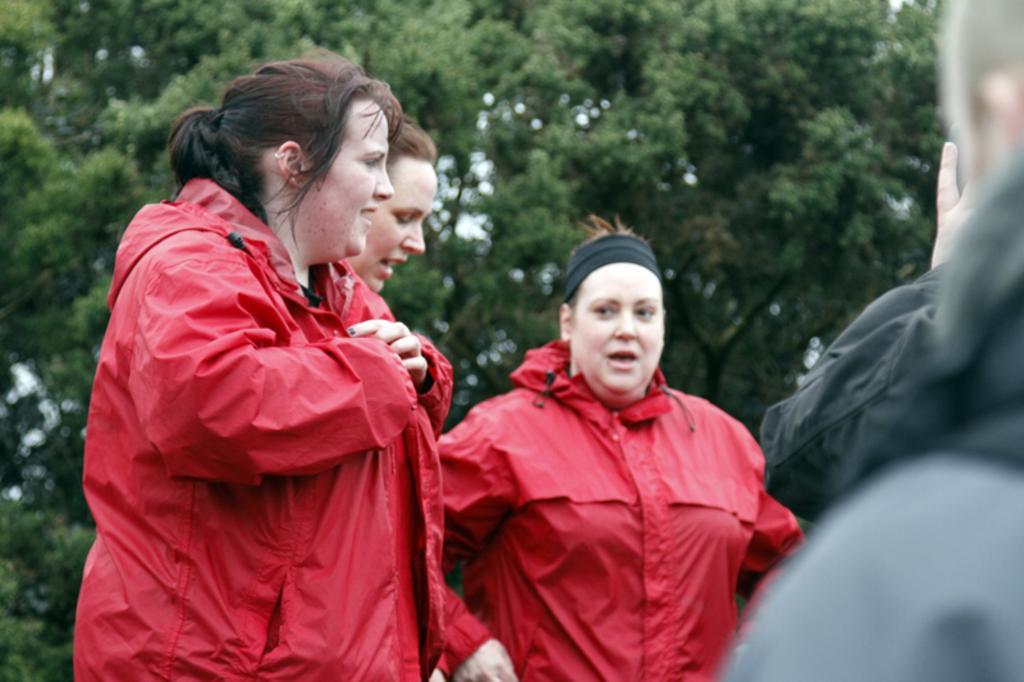In one or two sentences, can you explain what this image depicts? In this picture I can see few people standing and trees in the background. 